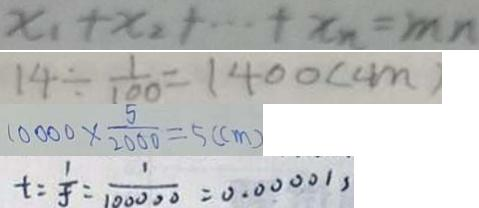<formula> <loc_0><loc_0><loc_500><loc_500>x _ { 1 } + x _ { 2 } + \cdots + x _ { n } = m n 
 1 4 \div \frac { 1 } { 1 0 0 } = 1 4 0 0 ( c m ) 
 1 0 0 0 0 \times \frac { 5 } { 2 0 0 0 } = 5 ( c m ) 
 t = \frac { 1 } { f } = \frac { 1 } { 1 0 0 0 0 0 } = 0 . 0 0 0 0 1 ,</formula> 